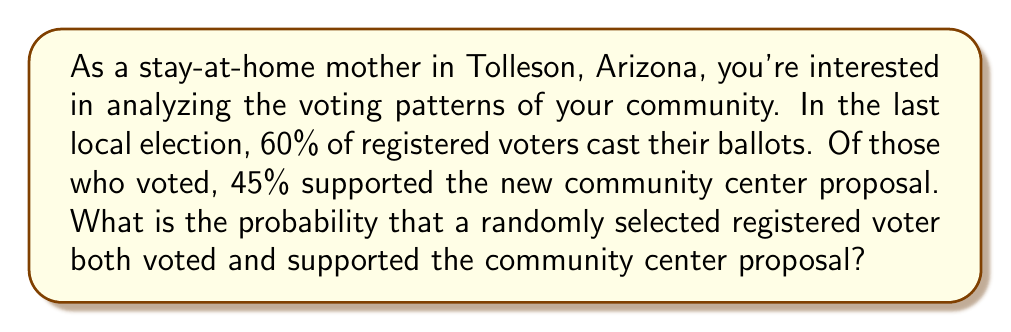Can you solve this math problem? Let's approach this step-by-step using probability concepts:

1) Let's define our events:
   A = the event that a registered voter cast a ballot
   B = the event that a voter supported the community center proposal

2) We're given the following information:
   P(A) = 0.60 (60% of registered voters cast their ballots)
   P(B|A) = 0.45 (45% of those who voted supported the proposal)

3) We're asked to find P(A and B), which is the probability that a registered voter both voted and supported the proposal.

4) We can use the multiplication rule of probability:

   $$P(A \text{ and } B) = P(A) \cdot P(B|A)$$

5) Substituting our known values:

   $$P(A \text{ and } B) = 0.60 \cdot 0.45$$

6) Calculating:

   $$P(A \text{ and } B) = 0.27$$

Therefore, the probability that a randomly selected registered voter both voted and supported the community center proposal is 0.27 or 27%.
Answer: 0.27 or 27% 